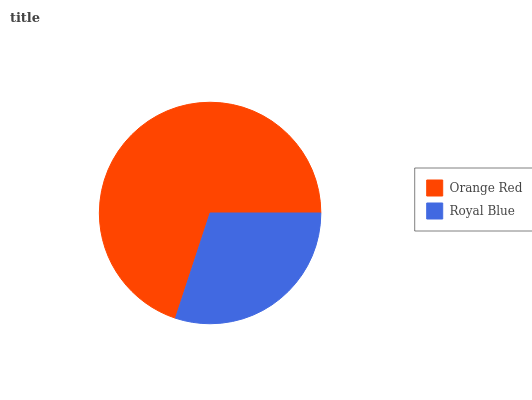Is Royal Blue the minimum?
Answer yes or no. Yes. Is Orange Red the maximum?
Answer yes or no. Yes. Is Royal Blue the maximum?
Answer yes or no. No. Is Orange Red greater than Royal Blue?
Answer yes or no. Yes. Is Royal Blue less than Orange Red?
Answer yes or no. Yes. Is Royal Blue greater than Orange Red?
Answer yes or no. No. Is Orange Red less than Royal Blue?
Answer yes or no. No. Is Orange Red the high median?
Answer yes or no. Yes. Is Royal Blue the low median?
Answer yes or no. Yes. Is Royal Blue the high median?
Answer yes or no. No. Is Orange Red the low median?
Answer yes or no. No. 